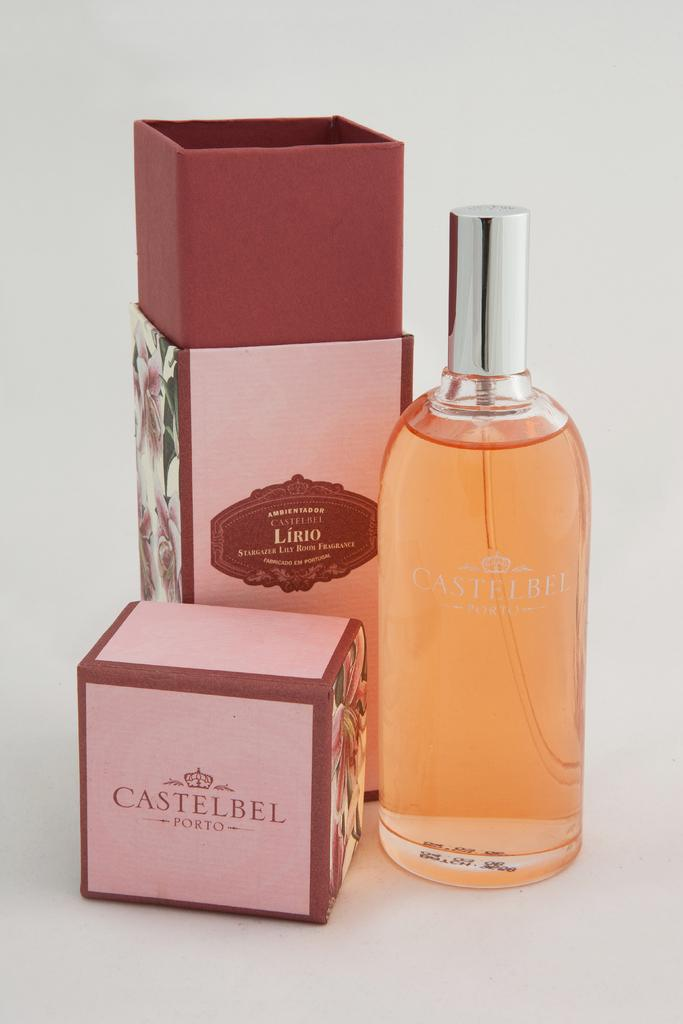<image>
Summarize the visual content of the image. A bottle and two boxes of Castelbel Porto scents. 